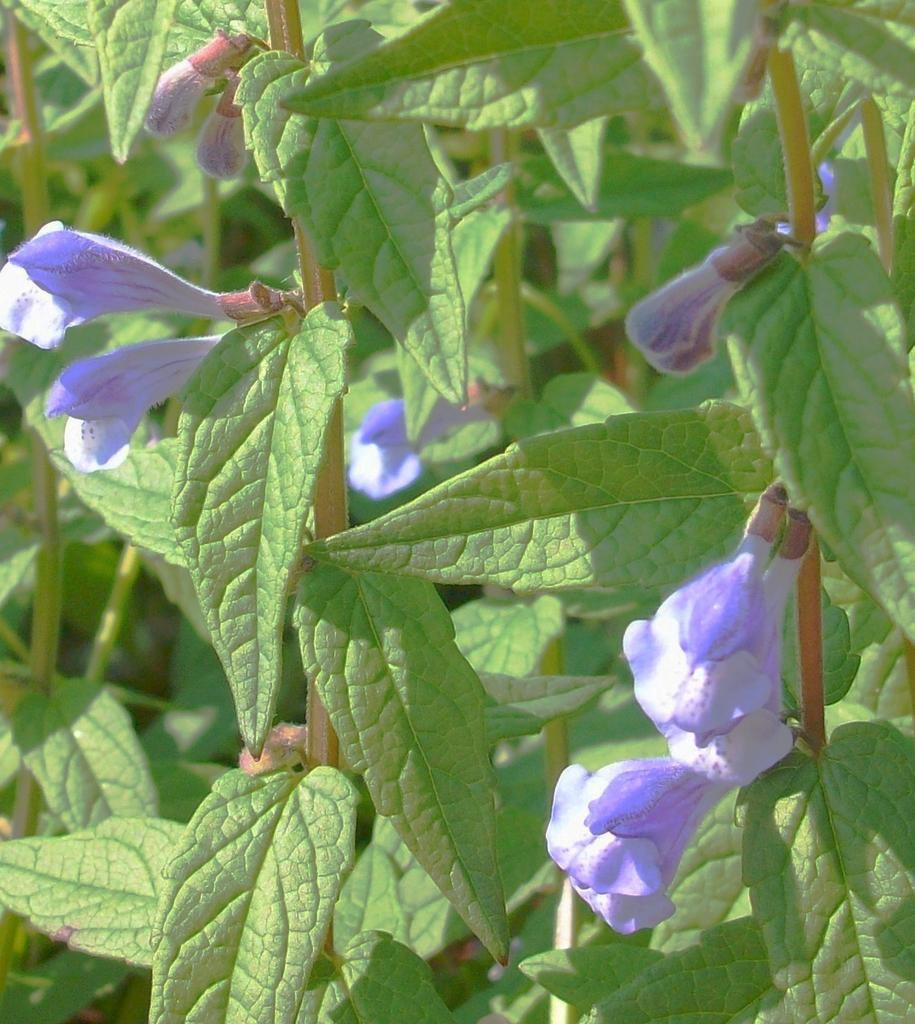What type of living organisms can be seen in the image? Plants can be seen in the image. What color are the flowers on the plants? The flowers on the plants are violet colored. How many stars can be seen in the image? There are no stars present in the image, as it features plants with violet flowers. Are there any spiders visible on the plants in the image? There is no mention of spiders in the image, which only features plants with violet flowers. 